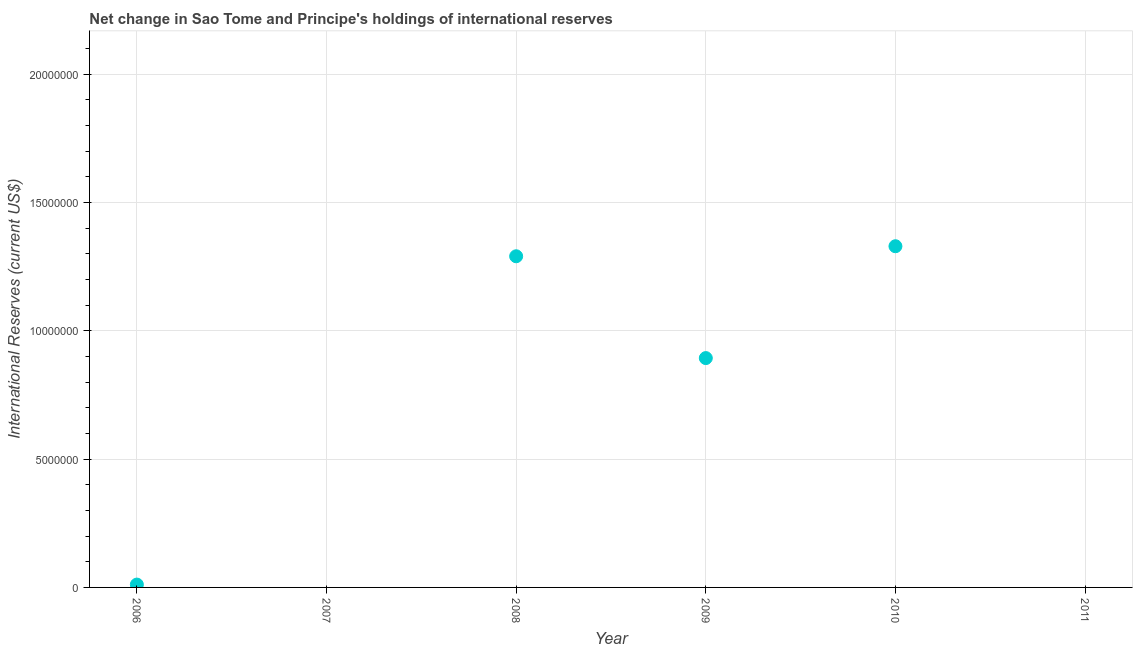What is the reserves and related items in 2010?
Ensure brevity in your answer.  1.33e+07. Across all years, what is the maximum reserves and related items?
Offer a very short reply. 1.33e+07. Across all years, what is the minimum reserves and related items?
Provide a succinct answer. 0. What is the sum of the reserves and related items?
Ensure brevity in your answer.  3.53e+07. What is the difference between the reserves and related items in 2006 and 2010?
Provide a short and direct response. -1.32e+07. What is the average reserves and related items per year?
Your answer should be compact. 5.88e+06. What is the median reserves and related items?
Provide a short and direct response. 4.52e+06. In how many years, is the reserves and related items greater than 19000000 US$?
Give a very brief answer. 0. What is the ratio of the reserves and related items in 2006 to that in 2009?
Keep it short and to the point. 0.01. Is the reserves and related items in 2008 less than that in 2010?
Provide a short and direct response. Yes. Is the difference between the reserves and related items in 2006 and 2009 greater than the difference between any two years?
Provide a short and direct response. No. What is the difference between the highest and the second highest reserves and related items?
Offer a terse response. 3.91e+05. What is the difference between the highest and the lowest reserves and related items?
Give a very brief answer. 1.33e+07. In how many years, is the reserves and related items greater than the average reserves and related items taken over all years?
Offer a very short reply. 3. How many years are there in the graph?
Make the answer very short. 6. What is the difference between two consecutive major ticks on the Y-axis?
Offer a very short reply. 5.00e+06. Does the graph contain any zero values?
Your answer should be very brief. Yes. Does the graph contain grids?
Your response must be concise. Yes. What is the title of the graph?
Provide a short and direct response. Net change in Sao Tome and Principe's holdings of international reserves. What is the label or title of the Y-axis?
Make the answer very short. International Reserves (current US$). What is the International Reserves (current US$) in 2006?
Give a very brief answer. 1.11e+05. What is the International Reserves (current US$) in 2008?
Provide a succinct answer. 1.29e+07. What is the International Reserves (current US$) in 2009?
Keep it short and to the point. 8.94e+06. What is the International Reserves (current US$) in 2010?
Keep it short and to the point. 1.33e+07. What is the International Reserves (current US$) in 2011?
Provide a short and direct response. 0. What is the difference between the International Reserves (current US$) in 2006 and 2008?
Provide a short and direct response. -1.28e+07. What is the difference between the International Reserves (current US$) in 2006 and 2009?
Give a very brief answer. -8.83e+06. What is the difference between the International Reserves (current US$) in 2006 and 2010?
Your answer should be compact. -1.32e+07. What is the difference between the International Reserves (current US$) in 2008 and 2009?
Offer a very short reply. 3.97e+06. What is the difference between the International Reserves (current US$) in 2008 and 2010?
Your answer should be very brief. -3.91e+05. What is the difference between the International Reserves (current US$) in 2009 and 2010?
Make the answer very short. -4.36e+06. What is the ratio of the International Reserves (current US$) in 2006 to that in 2008?
Provide a short and direct response. 0.01. What is the ratio of the International Reserves (current US$) in 2006 to that in 2009?
Ensure brevity in your answer.  0.01. What is the ratio of the International Reserves (current US$) in 2006 to that in 2010?
Offer a very short reply. 0.01. What is the ratio of the International Reserves (current US$) in 2008 to that in 2009?
Your answer should be compact. 1.44. What is the ratio of the International Reserves (current US$) in 2008 to that in 2010?
Offer a very short reply. 0.97. What is the ratio of the International Reserves (current US$) in 2009 to that in 2010?
Give a very brief answer. 0.67. 